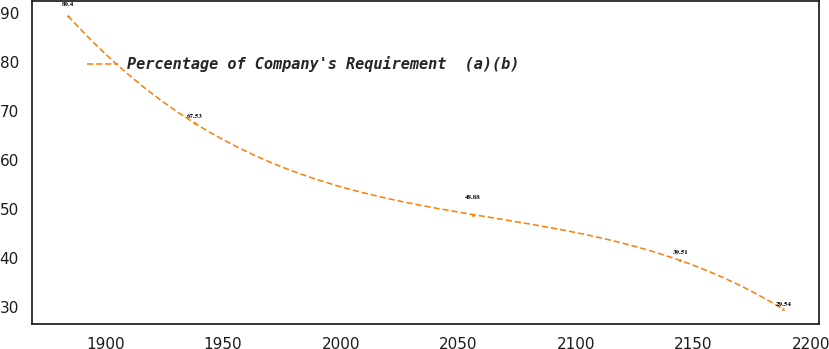<chart> <loc_0><loc_0><loc_500><loc_500><line_chart><ecel><fcel>Percentage of Company's Requirement  (a)(b)<nl><fcel>1884.01<fcel>89.4<nl><fcel>1937.85<fcel>67.53<nl><fcel>2056.14<fcel>48.88<nl><fcel>2144.34<fcel>39.51<nl><fcel>2188.18<fcel>29.54<nl></chart> 